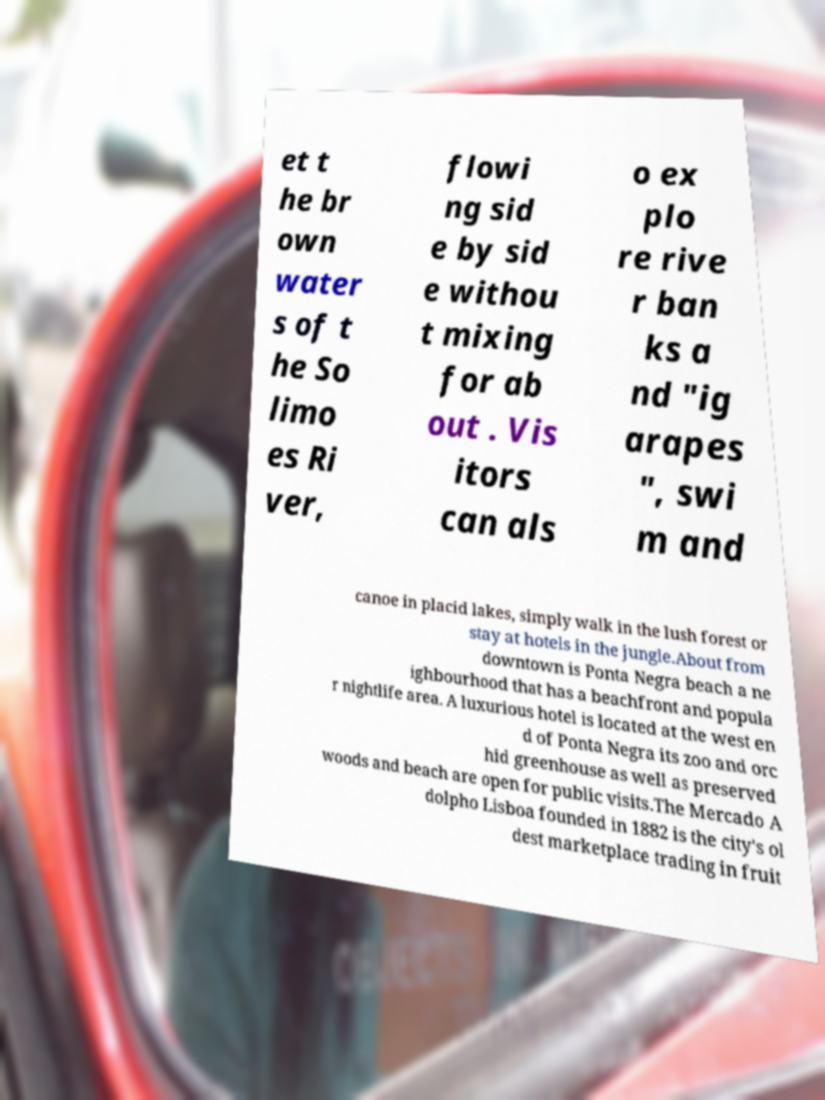There's text embedded in this image that I need extracted. Can you transcribe it verbatim? et t he br own water s of t he So limo es Ri ver, flowi ng sid e by sid e withou t mixing for ab out . Vis itors can als o ex plo re rive r ban ks a nd "ig arapes ", swi m and canoe in placid lakes, simply walk in the lush forest or stay at hotels in the jungle.About from downtown is Ponta Negra beach a ne ighbourhood that has a beachfront and popula r nightlife area. A luxurious hotel is located at the west en d of Ponta Negra its zoo and orc hid greenhouse as well as preserved woods and beach are open for public visits.The Mercado A dolpho Lisboa founded in 1882 is the city's ol dest marketplace trading in fruit 